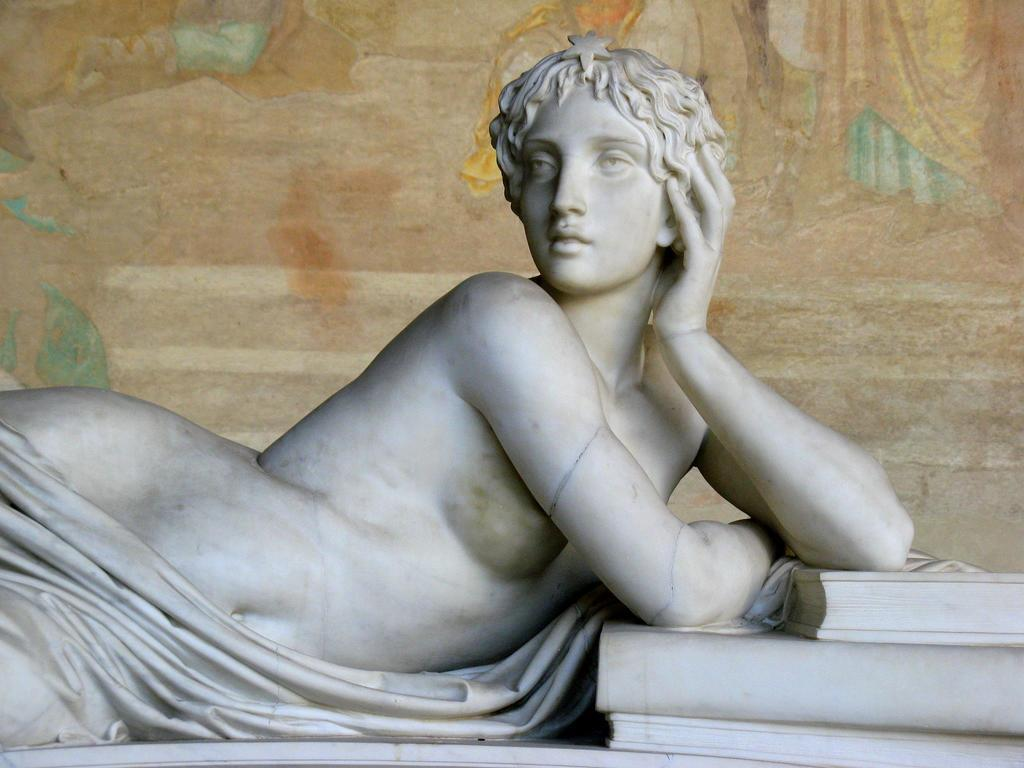What is the main subject of the image? There is a statue of a person in the image. What other objects can be seen in the image? There are books visible in the image. What can be seen on the wall in the background of the image? There is a painting on the wall in the background of the image. How does the statue exchange heat with the surrounding environment in the image? The statue does not exchange heat with the surrounding environment in the image, as it is a non-living object made of a material that does not conduct heat. 